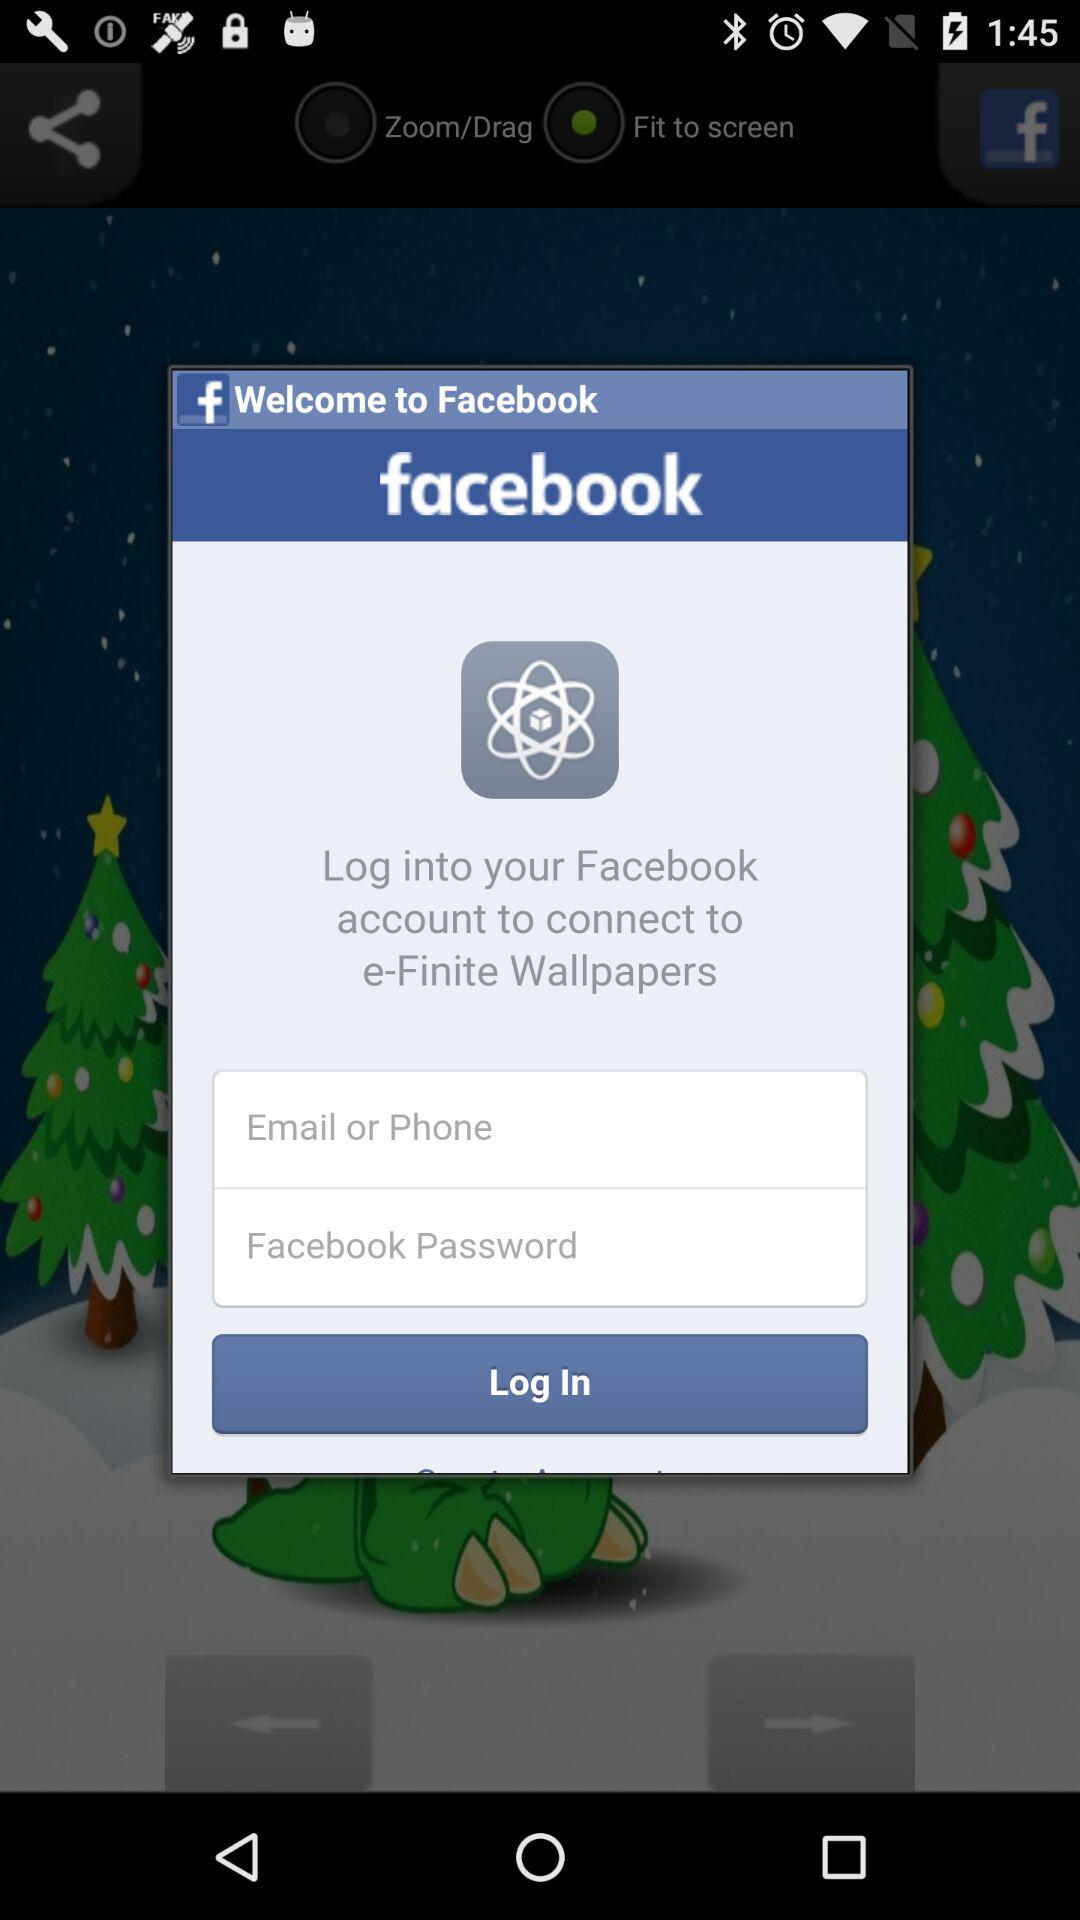To what application can we connect through "Facebook"? You can connect to "e-Finite Wallpapers" through "Facebook". 